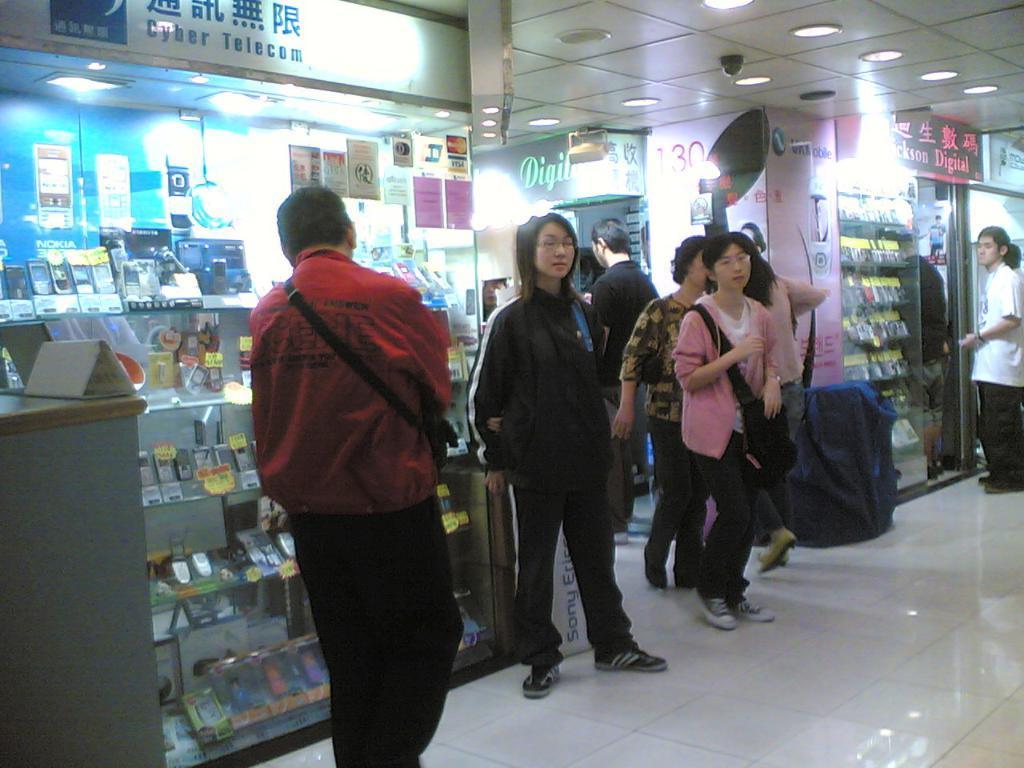Describe this image in one or two sentences. Here we can see few persons on the floor. There are stores, boards, mobiles, and lights. This is ceiling. 